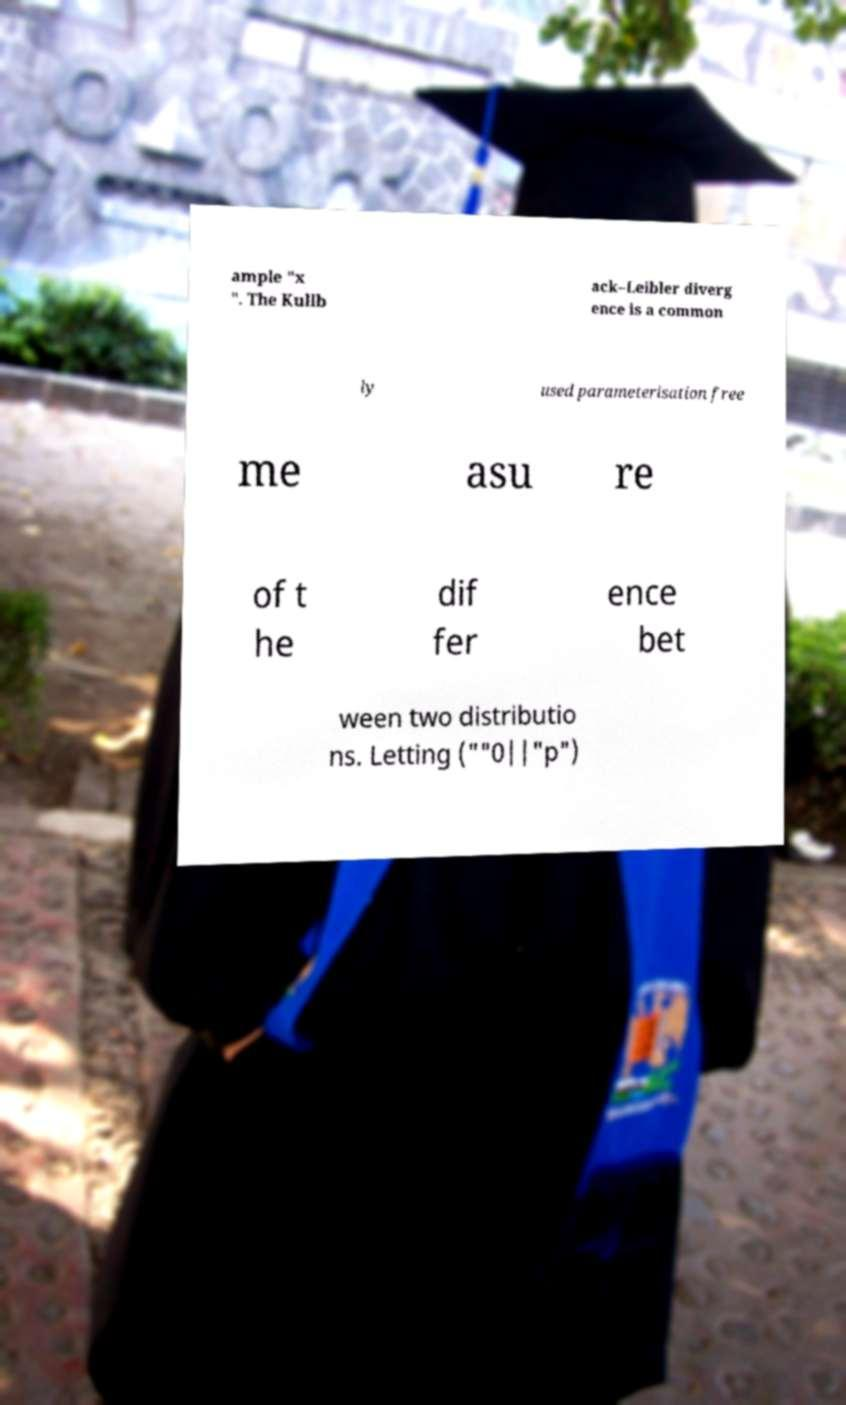For documentation purposes, I need the text within this image transcribed. Could you provide that? ample "x ". The Kullb ack–Leibler diverg ence is a common ly used parameterisation free me asu re of t he dif fer ence bet ween two distributio ns. Letting (""0||"p") 